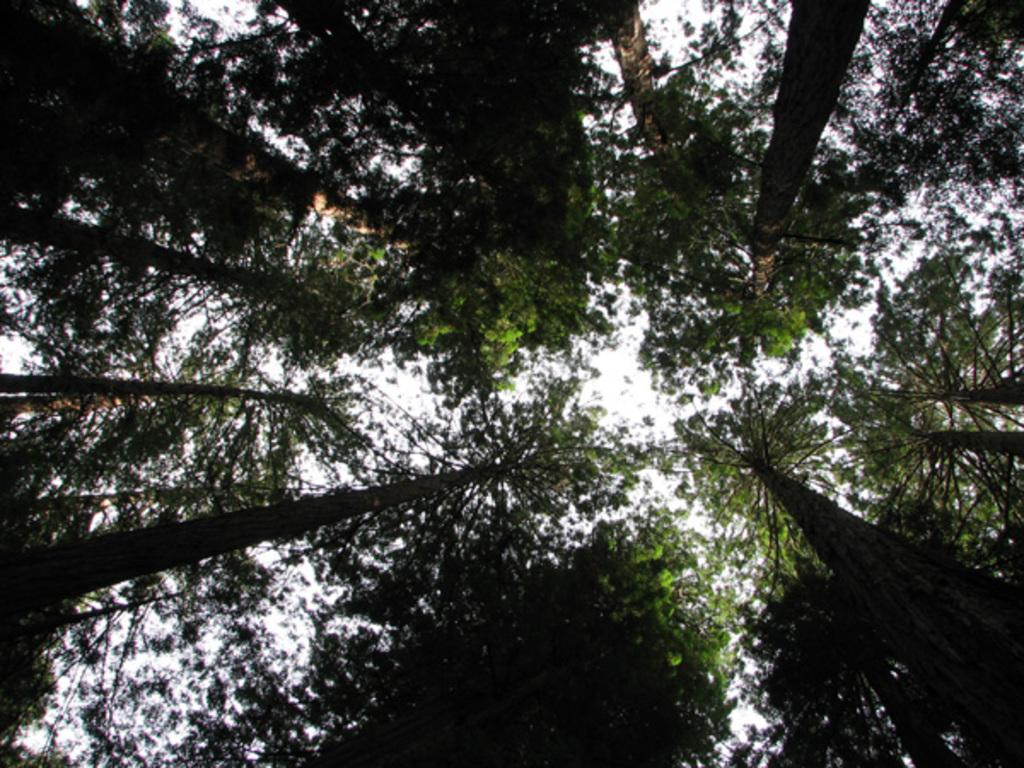What type of vegetation can be seen in the image? There are trees in the image. What part of the natural environment is visible in the image? The sky is visible in the image. Where might this image have been taken, considering the presence of trees? The image may have been taken in a forest, given the presence of trees. What type of pencil can be seen in the image? There is no pencil present in the image. What thrilling activity is taking place in the image? There is no thrilling activity depicted in the image; it primarily features trees and the sky. 